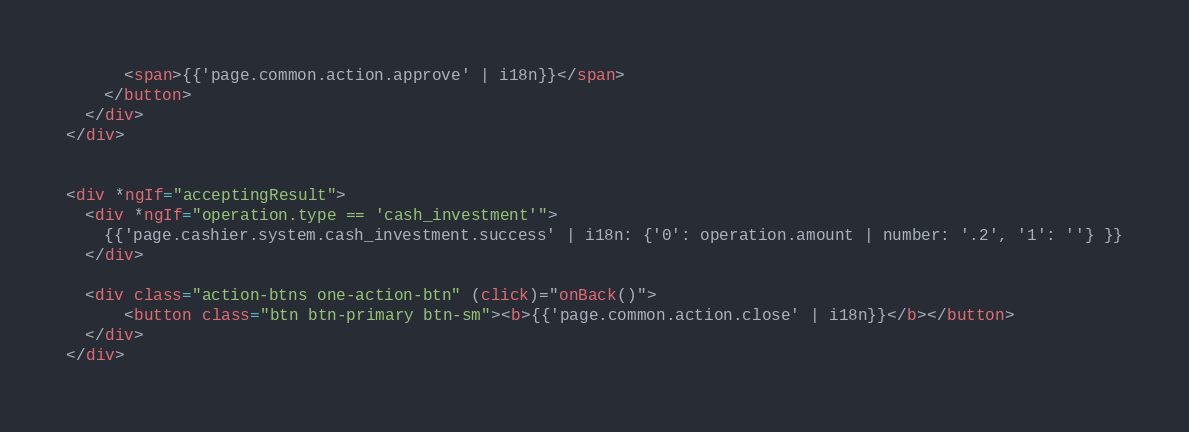<code> <loc_0><loc_0><loc_500><loc_500><_HTML_>      <span>{{'page.common.action.approve' | i18n}}</span>
    </button>
  </div>
</div>


<div *ngIf="acceptingResult">
  <div *ngIf="operation.type == 'cash_investment'">
    {{'page.cashier.system.cash_investment.success' | i18n: {'0': operation.amount | number: '.2', '1': ''} }}
  </div>

  <div class="action-btns one-action-btn" (click)="onBack()">
      <button class="btn btn-primary btn-sm"><b>{{'page.common.action.close' | i18n}}</b></button>
  </div>
</div>
</code> 